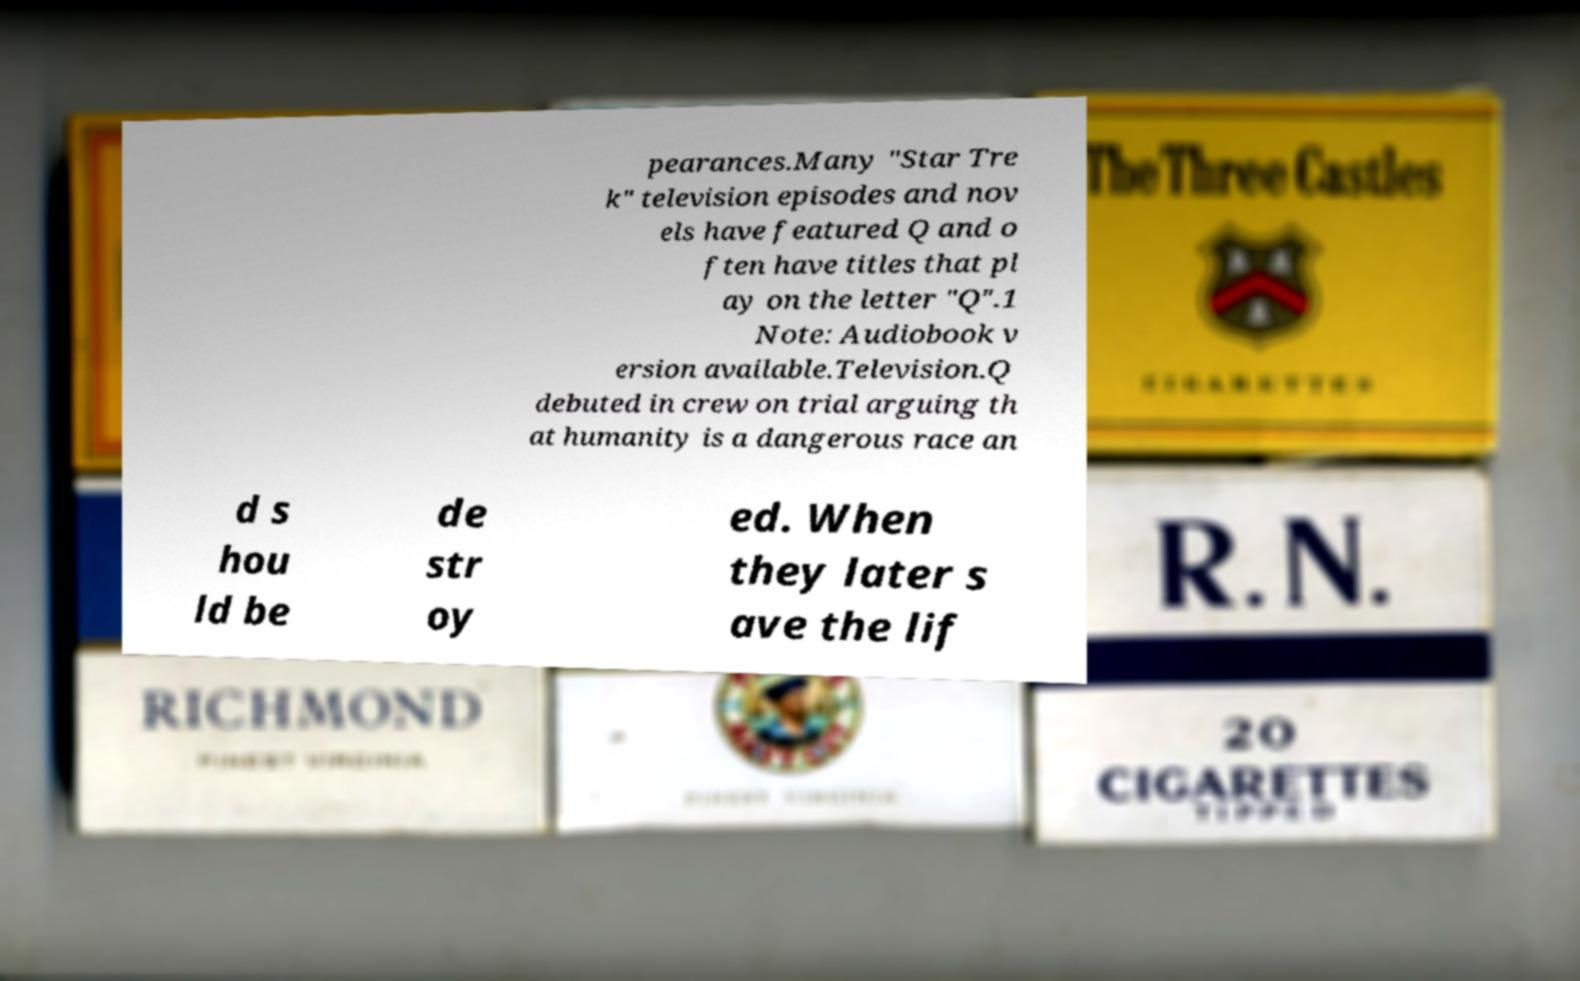Can you accurately transcribe the text from the provided image for me? pearances.Many "Star Tre k" television episodes and nov els have featured Q and o ften have titles that pl ay on the letter "Q".1 Note: Audiobook v ersion available.Television.Q debuted in crew on trial arguing th at humanity is a dangerous race an d s hou ld be de str oy ed. When they later s ave the lif 